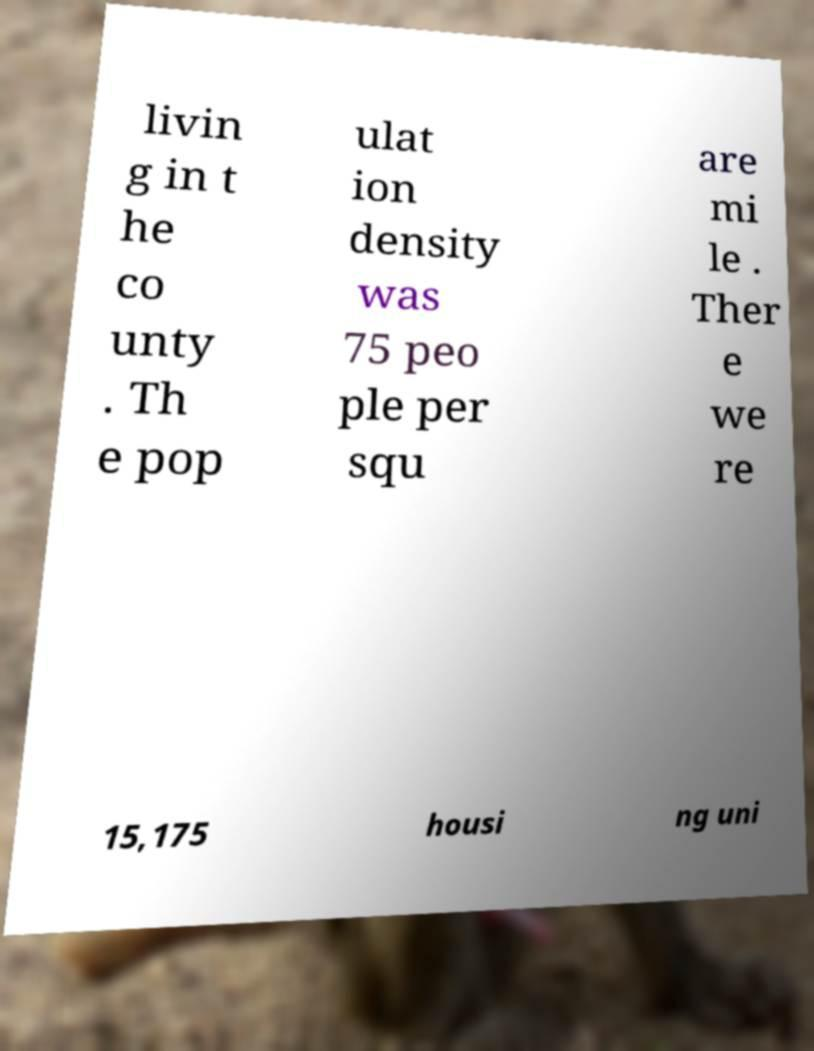Can you accurately transcribe the text from the provided image for me? livin g in t he co unty . Th e pop ulat ion density was 75 peo ple per squ are mi le . Ther e we re 15,175 housi ng uni 